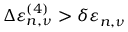Convert formula to latex. <formula><loc_0><loc_0><loc_500><loc_500>\Delta \varepsilon _ { n , \nu } ^ { ( 4 ) } > \delta \varepsilon _ { n , \nu }</formula> 